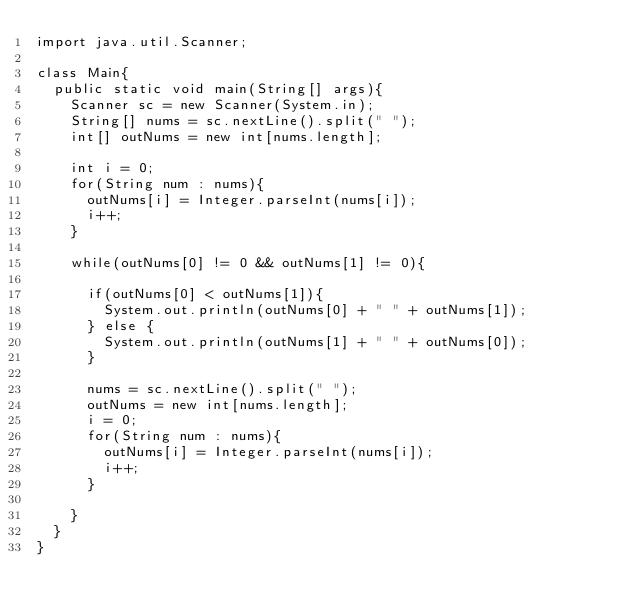Convert code to text. <code><loc_0><loc_0><loc_500><loc_500><_Java_>import java.util.Scanner;

class Main{
	public static void main(String[] args){
		Scanner sc = new Scanner(System.in);
		String[] nums = sc.nextLine().split(" ");
		int[] outNums = new int[nums.length];

		int i = 0;
		for(String num : nums){
			outNums[i] = Integer.parseInt(nums[i]);
			i++;
		}

		while(outNums[0] != 0 && outNums[1] != 0){

			if(outNums[0] < outNums[1]){
				System.out.println(outNums[0] + " " + outNums[1]);
			} else {
				System.out.println(outNums[1] + " " + outNums[0]);
			}
			
			nums = sc.nextLine().split(" ");
			outNums = new int[nums.length];
			i = 0;
			for(String num : nums){
				outNums[i] = Integer.parseInt(nums[i]);
				i++;
			}

		}
	}
}</code> 